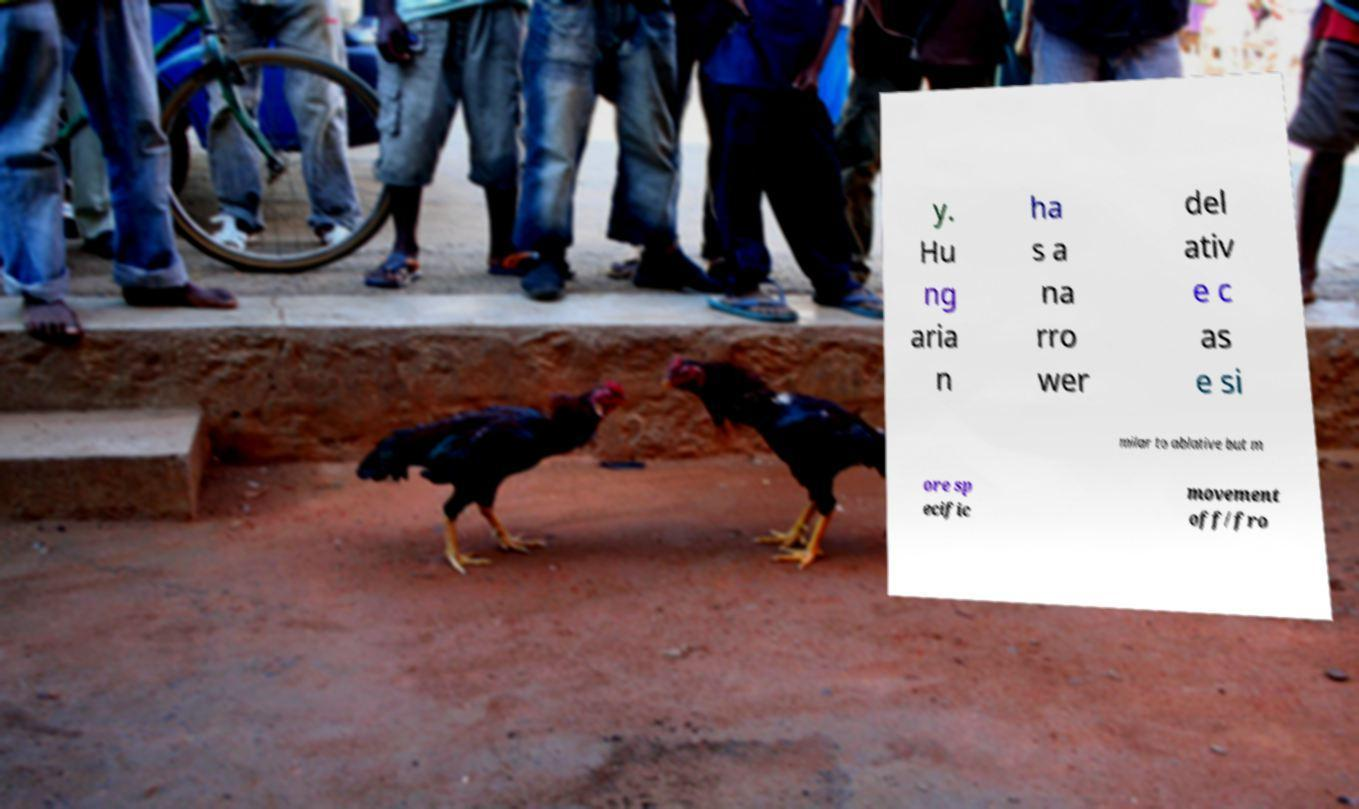What messages or text are displayed in this image? I need them in a readable, typed format. y. Hu ng aria n ha s a na rro wer del ativ e c as e si milar to ablative but m ore sp ecific movement off/fro 